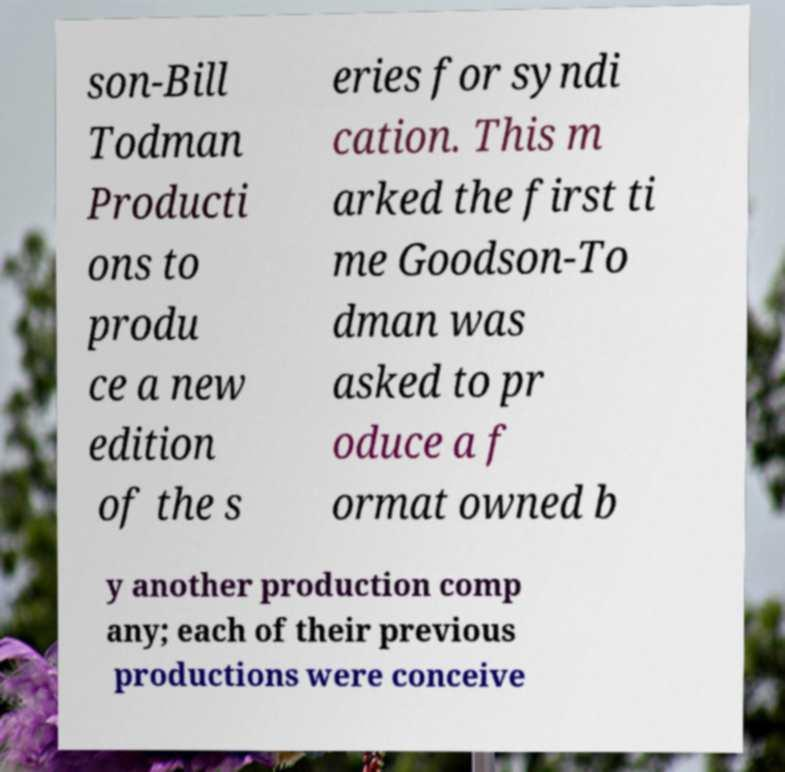Please read and relay the text visible in this image. What does it say? son-Bill Todman Producti ons to produ ce a new edition of the s eries for syndi cation. This m arked the first ti me Goodson-To dman was asked to pr oduce a f ormat owned b y another production comp any; each of their previous productions were conceive 